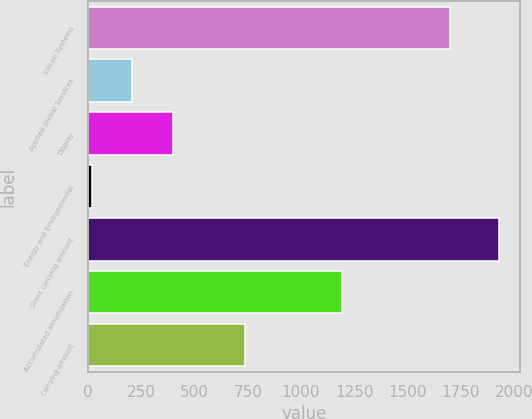Convert chart. <chart><loc_0><loc_0><loc_500><loc_500><bar_chart><fcel>Silicon Systems<fcel>Applied Global Services<fcel>Display<fcel>Energy and Environmental<fcel>Gross carrying amount<fcel>Accumulated amortization<fcel>Carrying amount<nl><fcel>1701<fcel>207.6<fcel>399.2<fcel>16<fcel>1932<fcel>1195<fcel>737<nl></chart> 